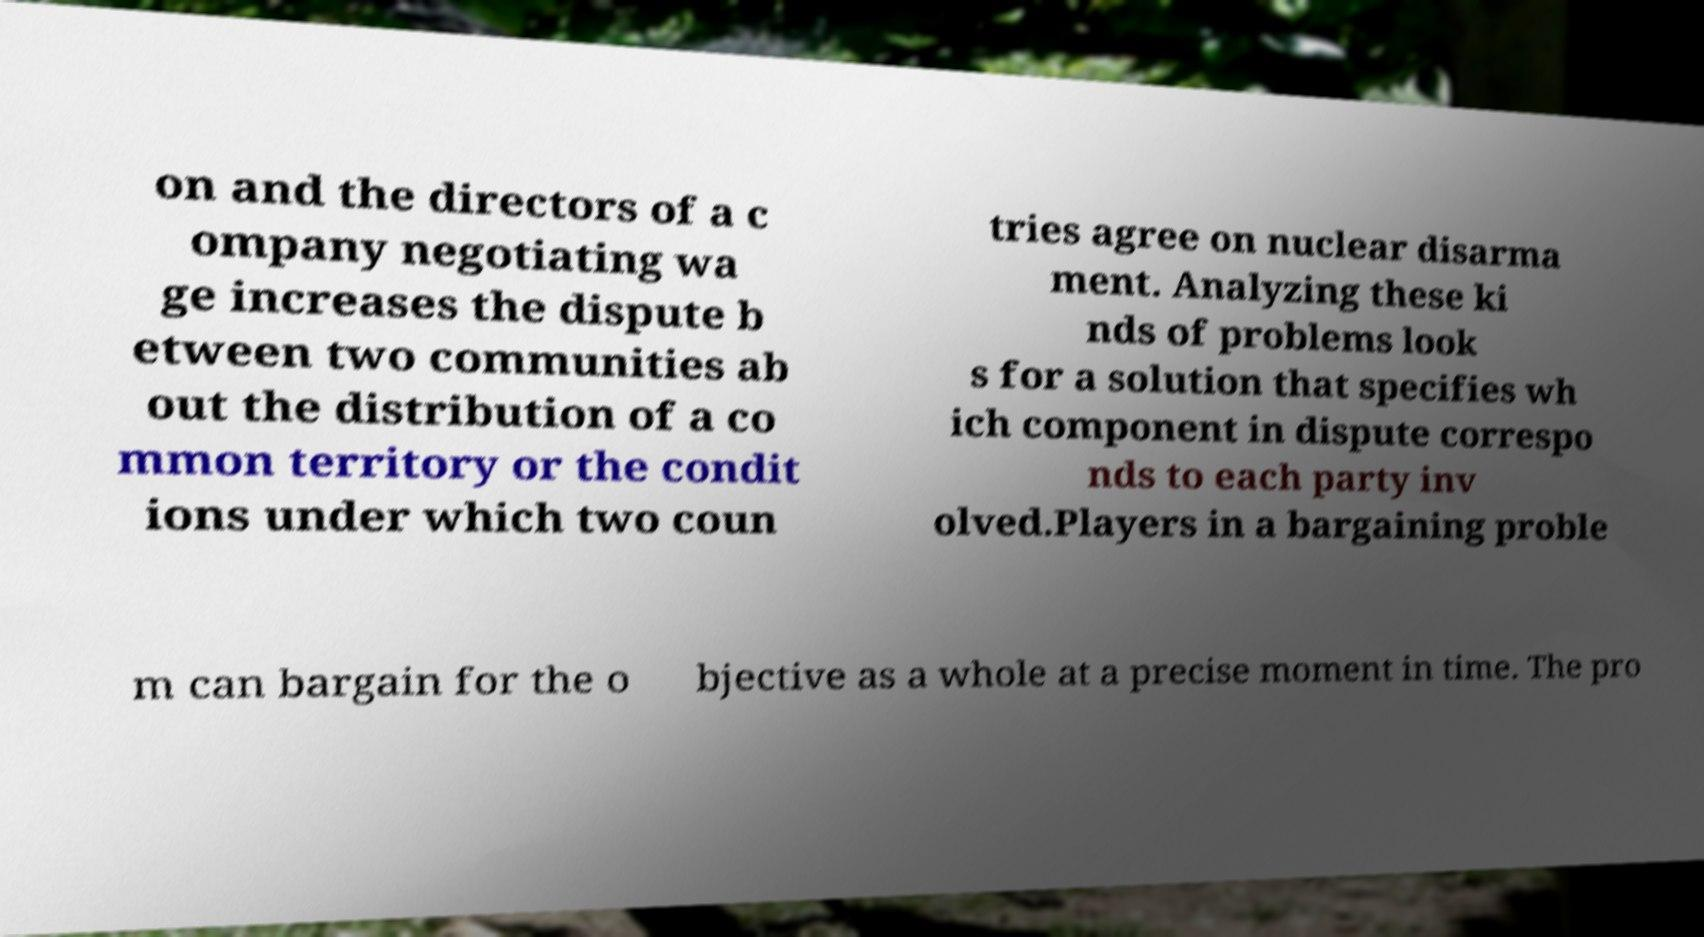Could you assist in decoding the text presented in this image and type it out clearly? on and the directors of a c ompany negotiating wa ge increases the dispute b etween two communities ab out the distribution of a co mmon territory or the condit ions under which two coun tries agree on nuclear disarma ment. Analyzing these ki nds of problems look s for a solution that specifies wh ich component in dispute correspo nds to each party inv olved.Players in a bargaining proble m can bargain for the o bjective as a whole at a precise moment in time. The pro 